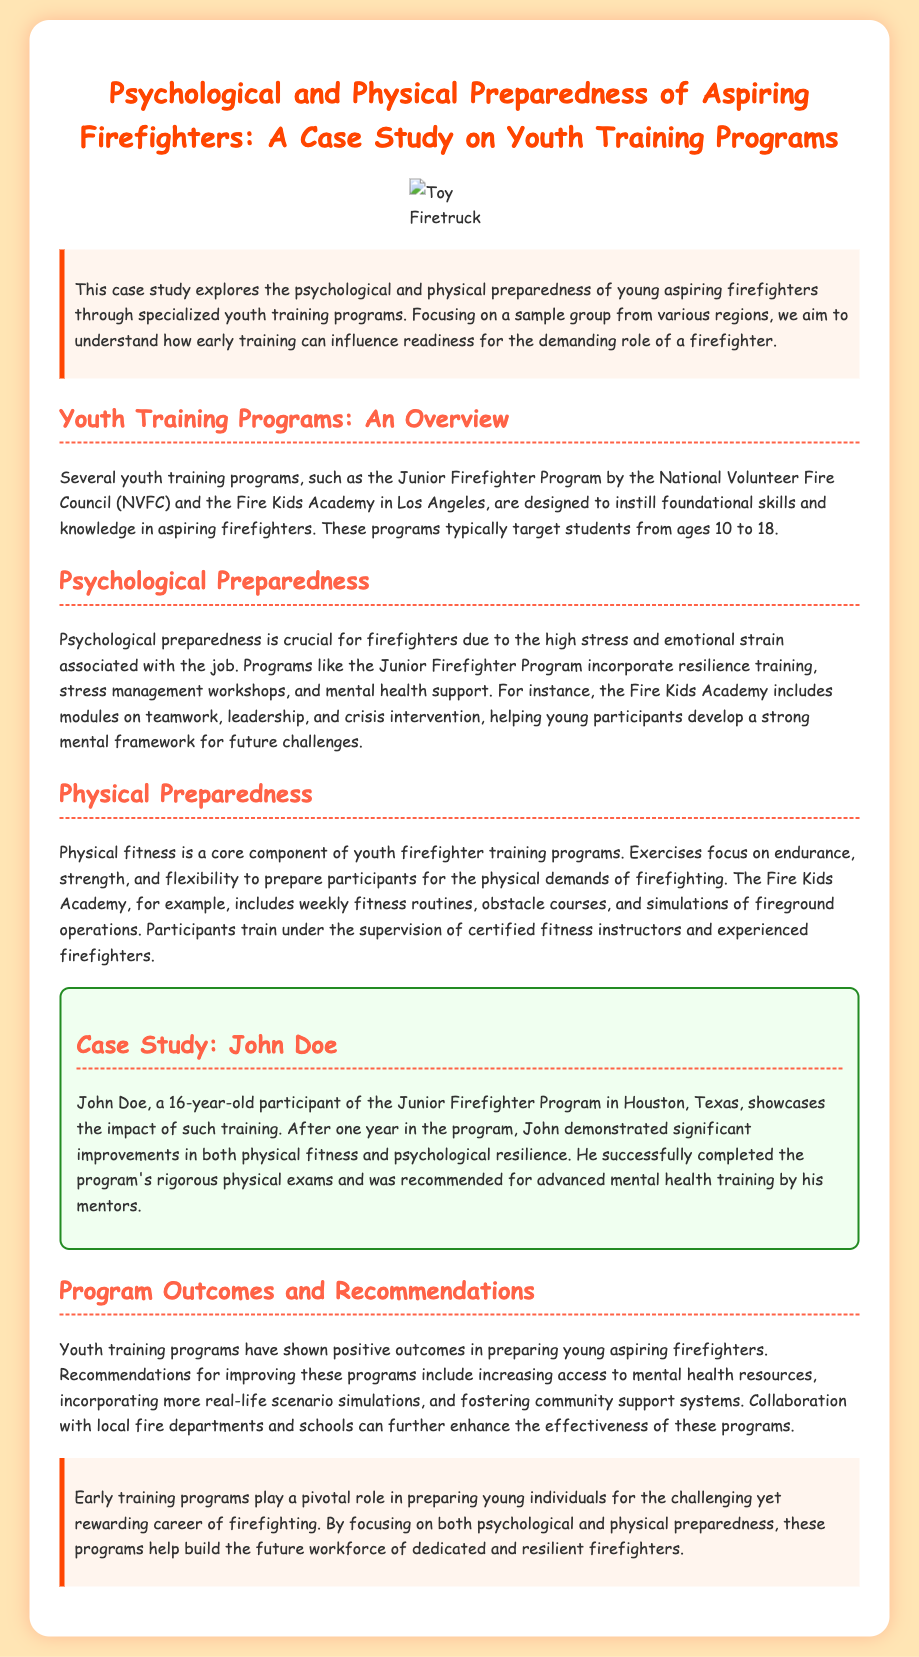What is the title of the case study? The title is mentioned at the beginning of the document.
Answer: Psychological and Physical Preparedness of Aspiring Firefighters: A Case Study on Youth Training Programs What age group do youth training programs target? The document specifies the age range targeted by these programs.
Answer: 10 to 18 Who is the case study focused on? The case study provides a personal example to illustrate the program's impact.
Answer: John Doe Which program includes resilience training? This information highlights the focus of specific programs on mental preparedness.
Answer: Junior Firefighter Program What type of training does the Fire Kids Academy include? The document lists specific activities included in the program.
Answer: Weekly fitness routines What are the recommended improvements for youth training programs? Recommendations are provided for enhancing the effectiveness of these programs.
Answer: Increase access to mental health resources How long did John participate in the training program? The document specifies the duration of John’s participation.
Answer: One year What is the background color of the document? The introductory section describes the visual presentation of the document.
Answer: #FFE5B4 